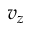Convert formula to latex. <formula><loc_0><loc_0><loc_500><loc_500>v _ { z }</formula> 